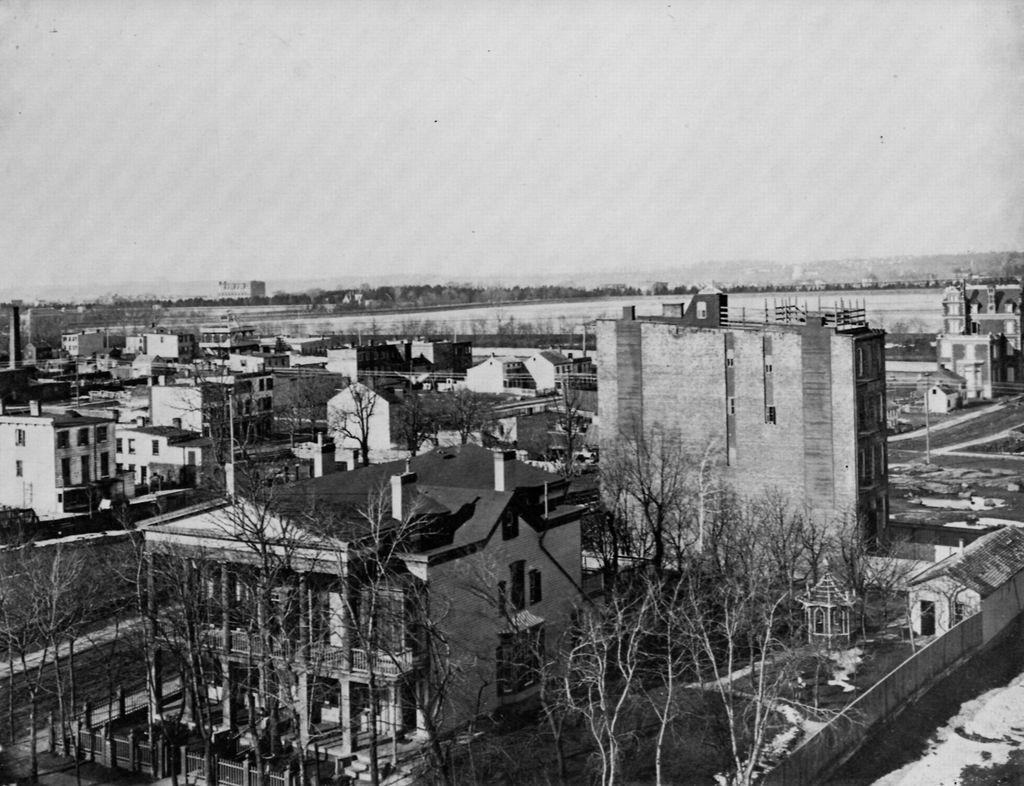Can you describe this image briefly? In the image I can see the top view of a place where we have some houses, buildings, trees and plants. 